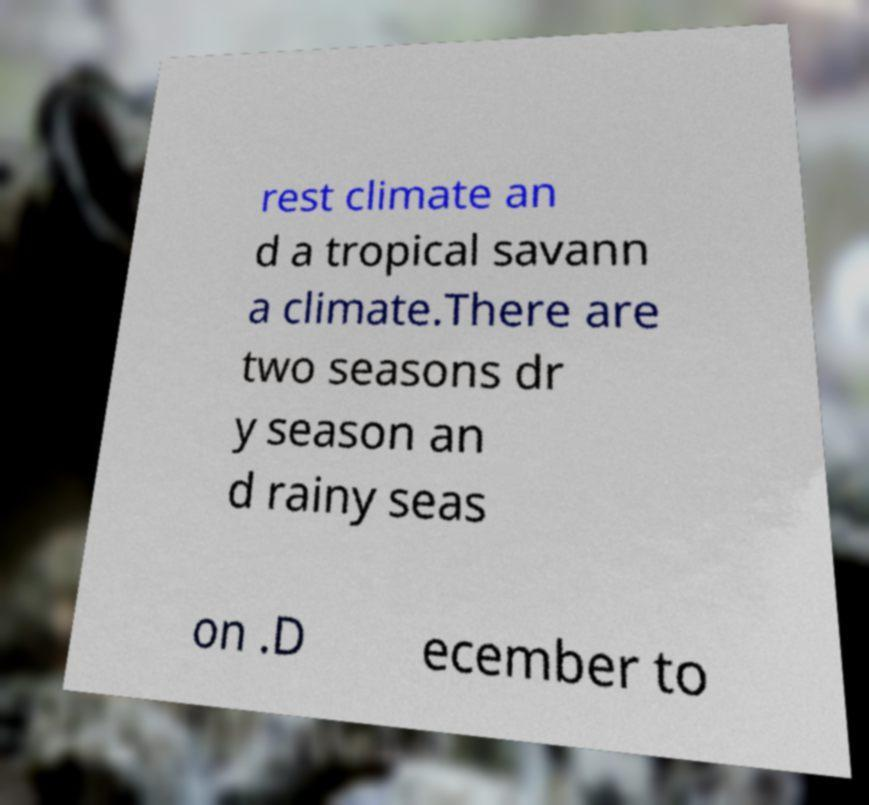Could you extract and type out the text from this image? rest climate an d a tropical savann a climate.There are two seasons dr y season an d rainy seas on .D ecember to 